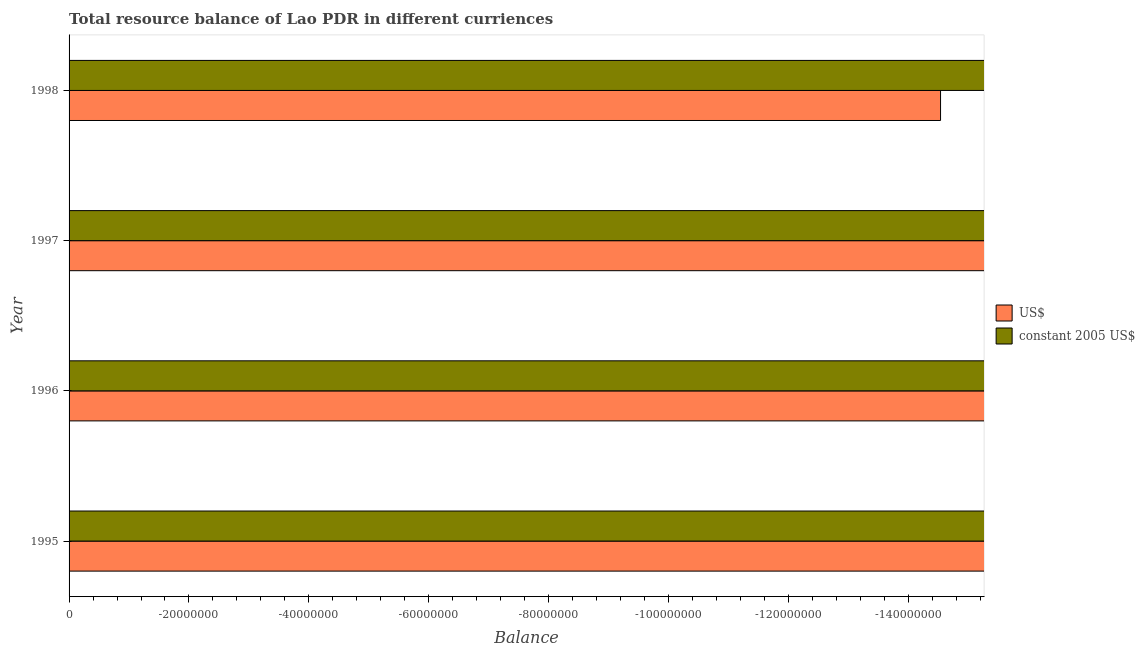How many different coloured bars are there?
Provide a short and direct response. 0. Are the number of bars per tick equal to the number of legend labels?
Ensure brevity in your answer.  No. Are the number of bars on each tick of the Y-axis equal?
Offer a terse response. Yes. What is the resource balance in constant us$ in 1995?
Your answer should be very brief. 0. Across all years, what is the minimum resource balance in constant us$?
Offer a terse response. 0. In how many years, is the resource balance in us$ greater than -136000000 units?
Offer a terse response. 0. How many bars are there?
Your response must be concise. 0. Are all the bars in the graph horizontal?
Provide a succinct answer. Yes. How many years are there in the graph?
Keep it short and to the point. 4. Does the graph contain grids?
Provide a short and direct response. No. Where does the legend appear in the graph?
Offer a very short reply. Center right. How many legend labels are there?
Provide a short and direct response. 2. What is the title of the graph?
Offer a very short reply. Total resource balance of Lao PDR in different curriences. What is the label or title of the X-axis?
Offer a very short reply. Balance. What is the label or title of the Y-axis?
Make the answer very short. Year. What is the Balance of US$ in 1995?
Provide a short and direct response. 0. What is the Balance of constant 2005 US$ in 1995?
Your response must be concise. 0. What is the Balance of US$ in 1997?
Give a very brief answer. 0. What is the Balance of constant 2005 US$ in 1998?
Your answer should be very brief. 0. What is the total Balance in constant 2005 US$ in the graph?
Your answer should be very brief. 0. What is the average Balance of US$ per year?
Make the answer very short. 0. 